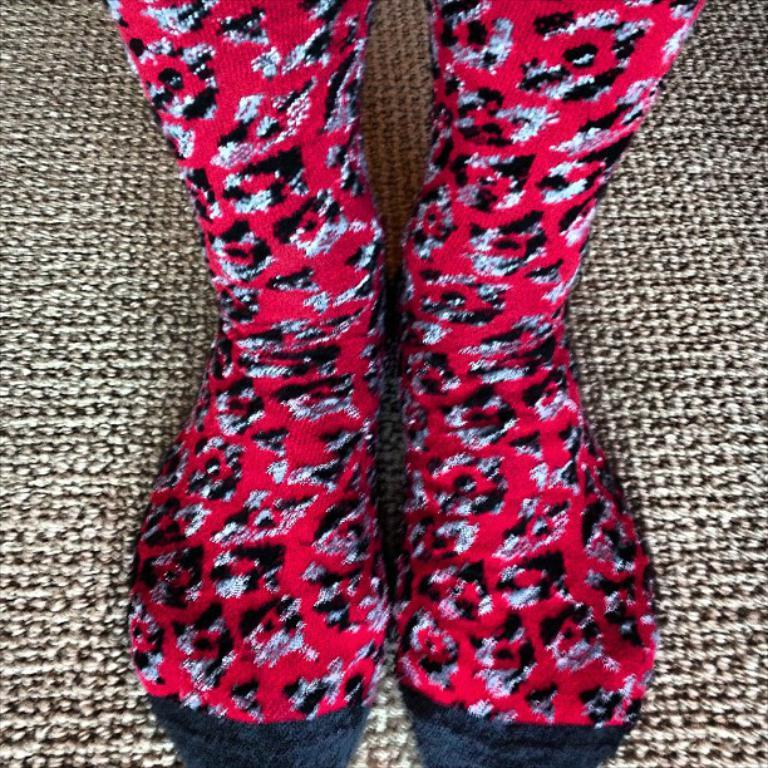What part of a person can be seen in the image? There are legs of a person visible in the image. What type of clothing is the person wearing on their feet? The person is wearing socks. What is the surface that the person's legs are standing on? The ground is visible in the image. Can you see a river flowing in the background of the image? There is no river visible in the image; only the person's legs and the ground are present. 